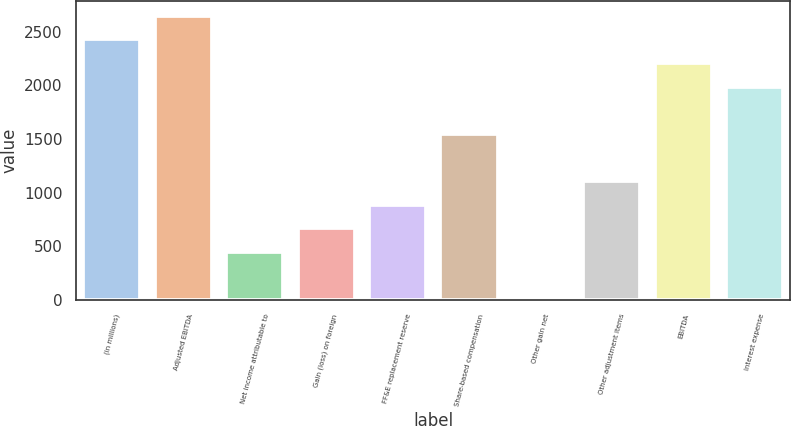<chart> <loc_0><loc_0><loc_500><loc_500><bar_chart><fcel>(in millions)<fcel>Adjusted EBITDA<fcel>Net income attributable to<fcel>Gain (loss) on foreign<fcel>FF&E replacement reserve<fcel>Share-based compensation<fcel>Other gain net<fcel>Other adjustment items<fcel>EBITDA<fcel>Interest expense<nl><fcel>2430.3<fcel>2650.6<fcel>447.6<fcel>667.9<fcel>888.2<fcel>1549.1<fcel>7<fcel>1108.5<fcel>2210<fcel>1989.7<nl></chart> 